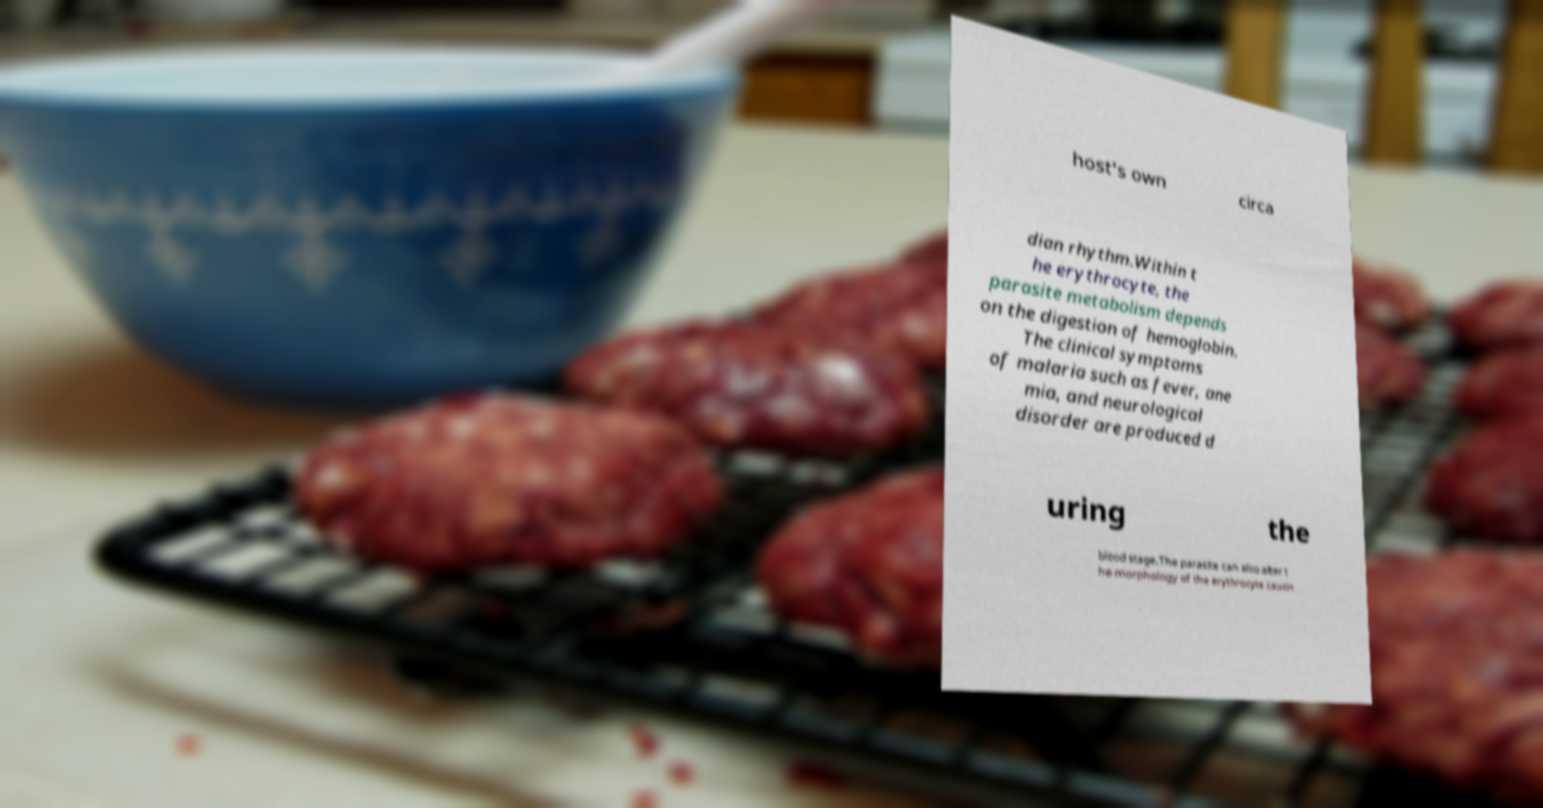Could you extract and type out the text from this image? host's own circa dian rhythm.Within t he erythrocyte, the parasite metabolism depends on the digestion of hemoglobin. The clinical symptoms of malaria such as fever, ane mia, and neurological disorder are produced d uring the blood stage.The parasite can also alter t he morphology of the erythrocyte causin 